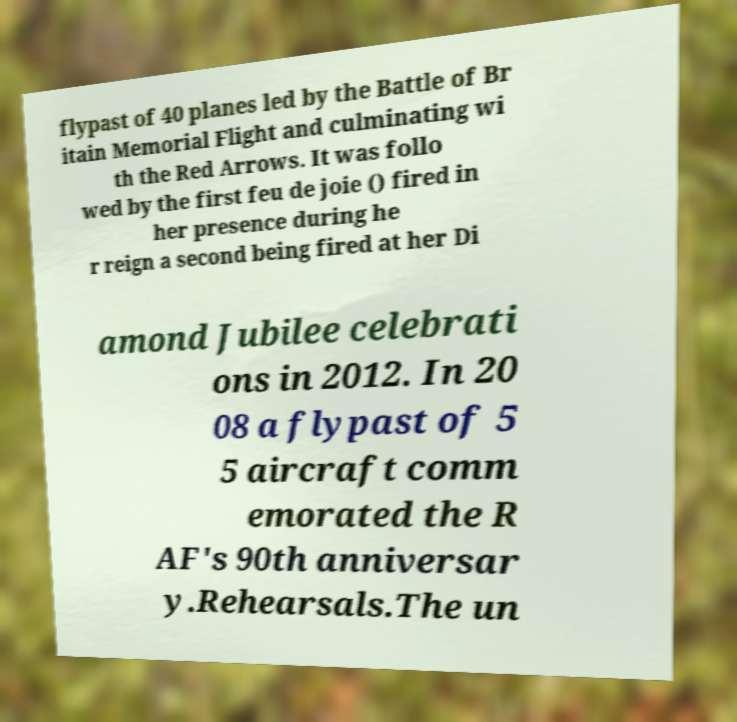There's text embedded in this image that I need extracted. Can you transcribe it verbatim? flypast of 40 planes led by the Battle of Br itain Memorial Flight and culminating wi th the Red Arrows. It was follo wed by the first feu de joie () fired in her presence during he r reign a second being fired at her Di amond Jubilee celebrati ons in 2012. In 20 08 a flypast of 5 5 aircraft comm emorated the R AF's 90th anniversar y.Rehearsals.The un 